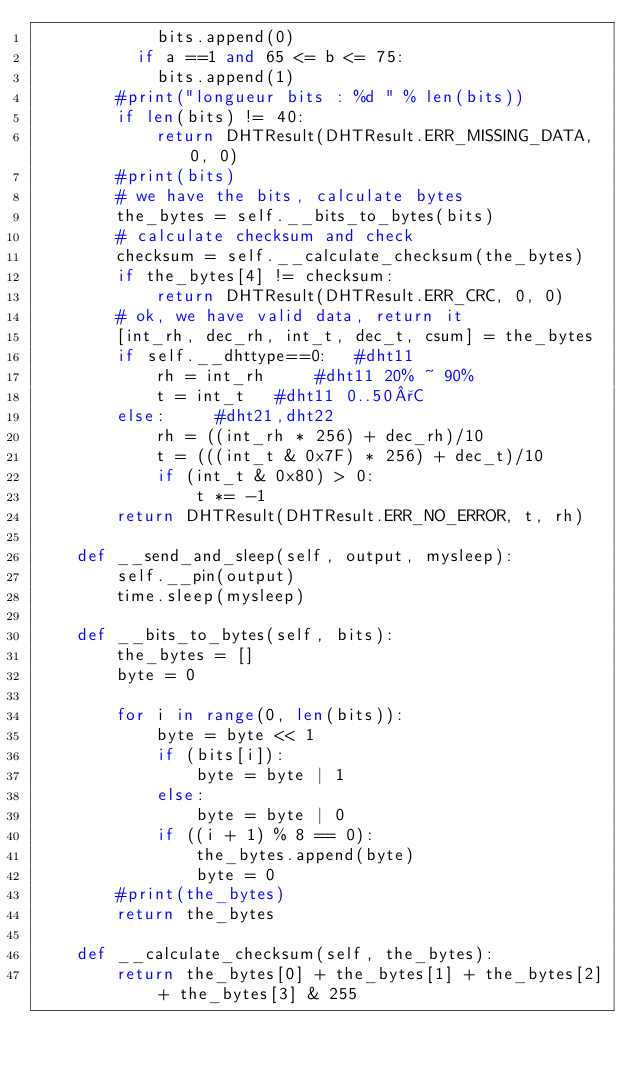<code> <loc_0><loc_0><loc_500><loc_500><_Python_>        		bits.append(0)
        	if a ==1 and 65 <= b <= 75:
        		bits.append(1)
        #print("longueur bits : %d " % len(bits))
        if len(bits) != 40:
            return DHTResult(DHTResult.ERR_MISSING_DATA, 0, 0)
        #print(bits)
        # we have the bits, calculate bytes
        the_bytes = self.__bits_to_bytes(bits)
        # calculate checksum and check
        checksum = self.__calculate_checksum(the_bytes)
        if the_bytes[4] != checksum:
            return DHTResult(DHTResult.ERR_CRC, 0, 0)
        # ok, we have valid data, return it
        [int_rh, dec_rh, int_t, dec_t, csum] = the_bytes
        if self.__dhttype==0:		#dht11
            rh = int_rh 		#dht11 20% ~ 90%
            t = int_t 	#dht11 0..50°C
        else:			#dht21,dht22
            rh = ((int_rh * 256) + dec_rh)/10
            t = (((int_t & 0x7F) * 256) + dec_t)/10
            if (int_t & 0x80) > 0:
                t *= -1
        return DHTResult(DHTResult.ERR_NO_ERROR, t, rh)

    def __send_and_sleep(self, output, mysleep):
        self.__pin(output)
        time.sleep(mysleep)

    def __bits_to_bytes(self, bits):
        the_bytes = []
        byte = 0

        for i in range(0, len(bits)):
            byte = byte << 1
            if (bits[i]):
                byte = byte | 1
            else:
                byte = byte | 0
            if ((i + 1) % 8 == 0):
                the_bytes.append(byte)
                byte = 0
        #print(the_bytes)
        return the_bytes

    def __calculate_checksum(self, the_bytes):
        return the_bytes[0] + the_bytes[1] + the_bytes[2] + the_bytes[3] & 255
</code> 